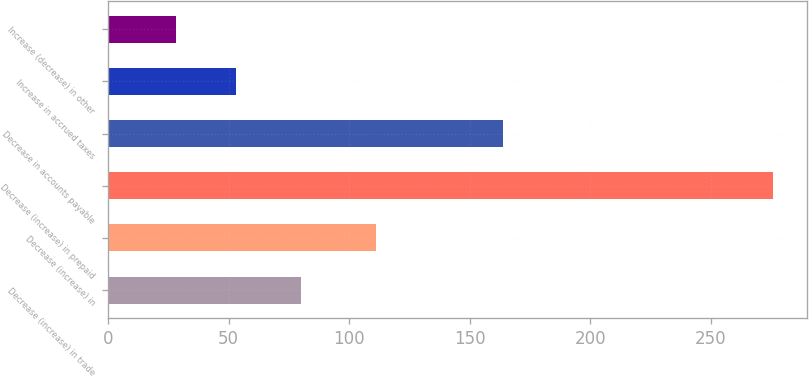Convert chart. <chart><loc_0><loc_0><loc_500><loc_500><bar_chart><fcel>Decrease (increase) in trade<fcel>Decrease (increase) in<fcel>Decrease (increase) in prepaid<fcel>Decrease in accounts payable<fcel>Increase in accrued taxes<fcel>Increase (decrease) in other<nl><fcel>80<fcel>111<fcel>276<fcel>164<fcel>53<fcel>28<nl></chart> 